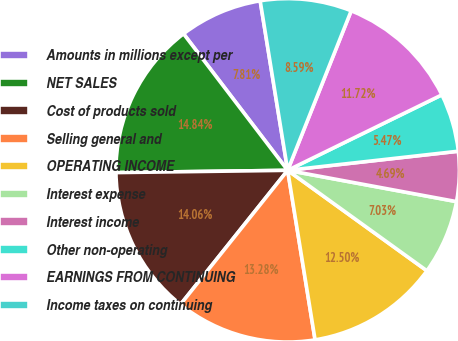Convert chart. <chart><loc_0><loc_0><loc_500><loc_500><pie_chart><fcel>Amounts in millions except per<fcel>NET SALES<fcel>Cost of products sold<fcel>Selling general and<fcel>OPERATING INCOME<fcel>Interest expense<fcel>Interest income<fcel>Other non-operating<fcel>EARNINGS FROM CONTINUING<fcel>Income taxes on continuing<nl><fcel>7.81%<fcel>14.84%<fcel>14.06%<fcel>13.28%<fcel>12.5%<fcel>7.03%<fcel>4.69%<fcel>5.47%<fcel>11.72%<fcel>8.59%<nl></chart> 